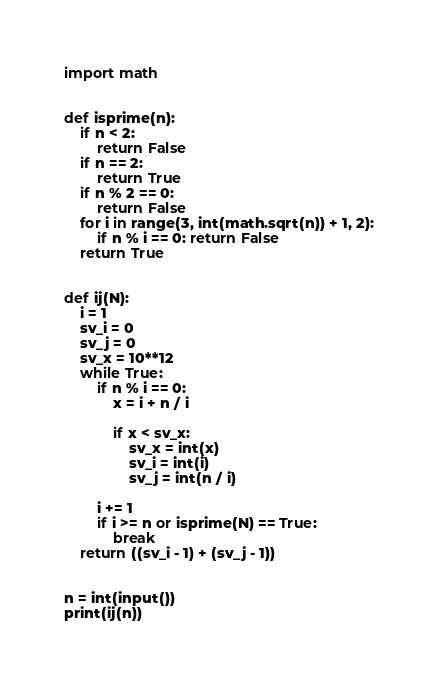Convert code to text. <code><loc_0><loc_0><loc_500><loc_500><_Python_>import math


def isprime(n):
    if n < 2:
        return False
    if n == 2:
        return True
    if n % 2 == 0:
        return False
    for i in range(3, int(math.sqrt(n)) + 1, 2):
        if n % i == 0: return False
    return True


def ij(N):
    i = 1
    sv_i = 0
    sv_j = 0
    sv_x = 10**12
    while True:
        if n % i == 0:
            x = i + n / i

            if x < sv_x:
                sv_x = int(x)
                sv_i = int(i)
                sv_j = int(n / i)

        i += 1
        if i >= n or isprime(N) == True:
            break
    return ((sv_i - 1) + (sv_j - 1))


n = int(input())
print(ij(n))
</code> 